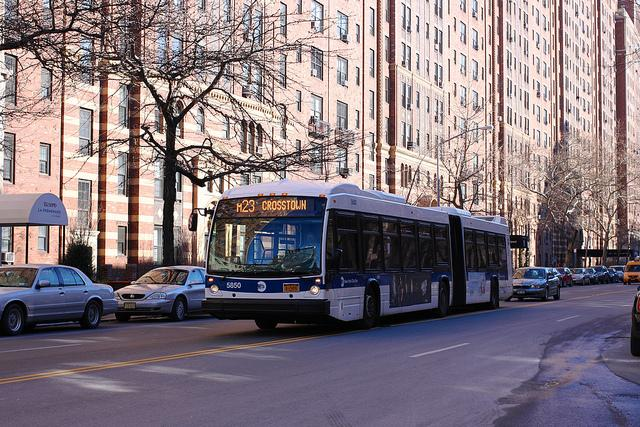What type of parking is shown? parallel 